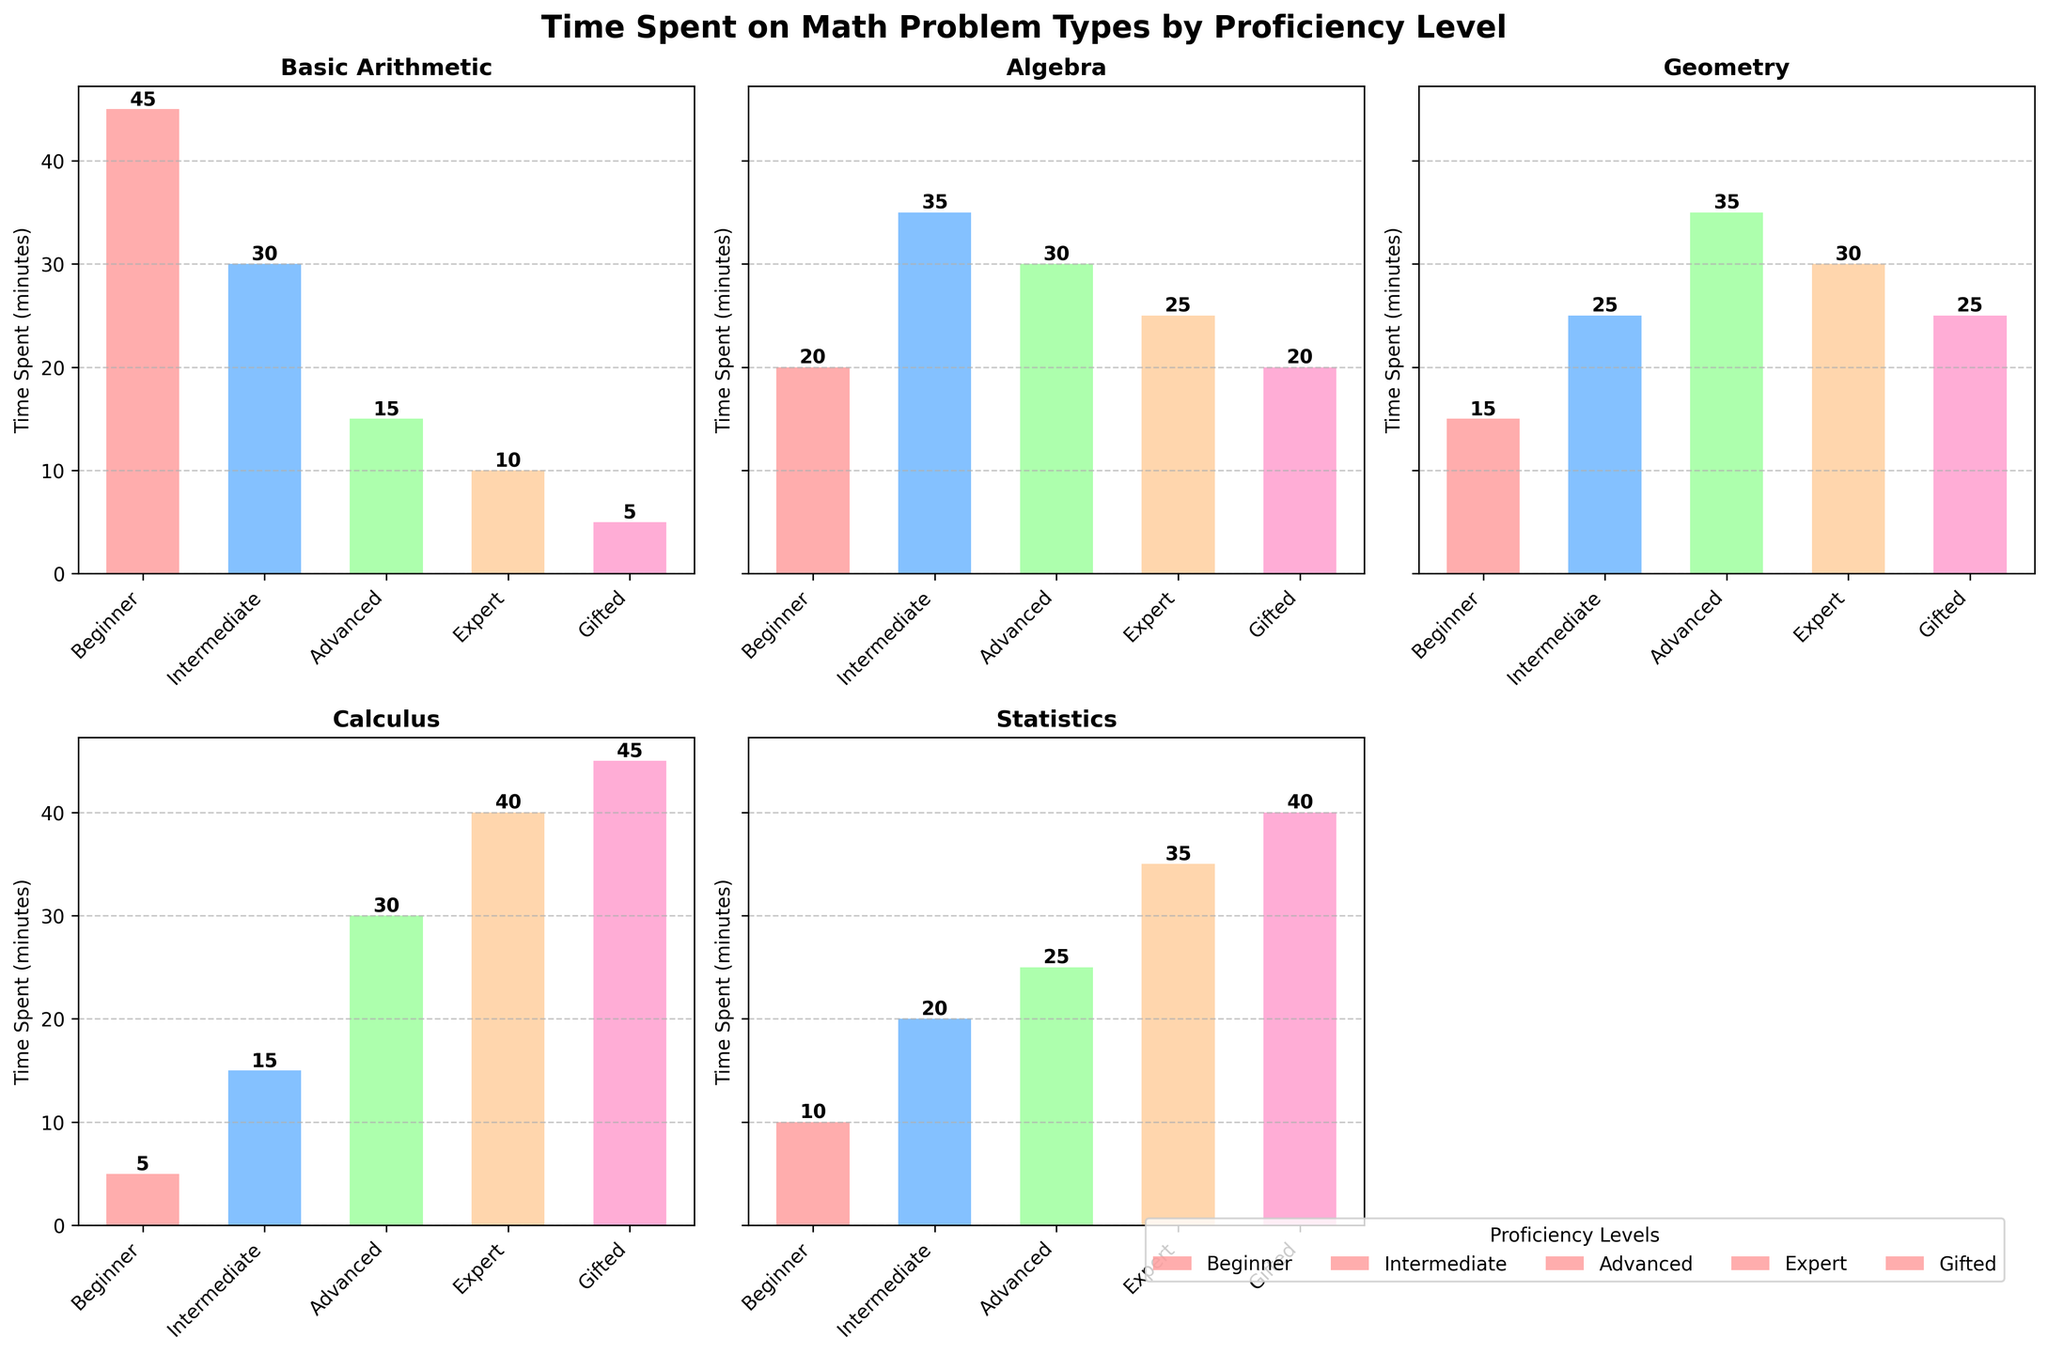Which proficiency level spends the most time on Calculus problems? The bar for Calculus under each proficiency level should be examined. The highest bar for Calculus is for the Gifted level, indicating it spends the most time.
Answer: Gifted Which problem type has the highest average time spent across all proficiency levels? Calculate the average time for each problem type by summing the times and dividing by the number of levels (5). Basic Arithmetic: (45+30+15+10+5)/5=21, Algebra: (20+35+30+25+20)/5=26, Geometry: (15+25+35+30+25)/5=26, Calculus: (5+15+30+40+45)/5=27, Statistics: (10+20+25+35+40)/5=26. The highest average is for Calculus.
Answer: Calculus Which proficiency level spends the least time on Basic Arithmetic problems? The bar for Basic Arithmetic under each proficiency level should be examined. The lowest bar is for the Gifted level, indicating it spends the least time.
Answer: Gifted By how much does the time spent on Statistics by an Expert differ from that by an Intermediate student? Compare the Expert and Intermediate bars for Statistics. Expert spends 35 minutes, and Intermediate spends 20 minutes. The difference is 35 - 20 = 15.
Answer: 15 minutes What is the total time spent on all problem types by the Advanced proficiency level? Sum the times for the Advanced level: 15 (Arithmetic) + 30 (Algebra) + 35 (Geometry) + 30 (Calculus) + 25 (Statistics). The total is 135.
Answer: 135 minutes Which problem type sees the greatest increase in time spent from Beginner to Gifted proficiency level? Calculate the difference in time spent for each problem type between Beginner and Gifted: Basic Arithmetic: 45-5=40, Algebra: 20-20=0, Geometry: 15-25=10, Calculus: 5-45=40, Statistics: 10-40=30. Greatest increase is for Basic Arithmetic and Calculus.
Answer: Basic Arithmetic and Calculus Is the time spent on Geometry problems by Intermediate students greater than the time spent on Algebra problems by Beginner students? Compare the bars for Geometry (Intermediate) and Algebra (Beginner). Geometry (Intermediate) = 25, Algebra (Beginner) = 20. Yes, 25 > 20.
Answer: Yes Which problem type do Intermediate students spend the most time on? Examine the bars for Intermediate level. The problem type with the highest bar is Algebra, indicating it spends the most time there.
Answer: Algebra What is the difference in time spent on Basic Arithmetic problems between the Beginner and Expert proficiency levels? Compare the bars for Basic Arithmetic of Beginner and Expert levels. Beginner = 45, Expert = 10. The difference is 45 - 10 = 35.
Answer: 35 minutes By how much does the time spent on Calculus by an Expert exceed the time spent by an Advanced student? Compare the bars for Calculus between Expert and Advanced levels. Expert = 40, Advanced = 30. The difference is 40 - 30 = 10.
Answer: 10 minutes 